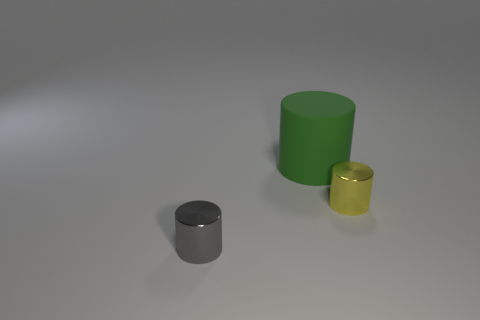Add 2 green things. How many objects exist? 5 Add 3 rubber things. How many rubber things are left? 4 Add 1 small gray things. How many small gray things exist? 2 Subtract 0 brown cylinders. How many objects are left? 3 Subtract all yellow shiny objects. Subtract all tiny blue shiny objects. How many objects are left? 2 